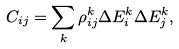Convert formula to latex. <formula><loc_0><loc_0><loc_500><loc_500>C _ { i j } = \sum _ { k } \rho ^ { k } _ { i j } \Delta E ^ { k } _ { i } \Delta E ^ { k } _ { j } ,</formula> 